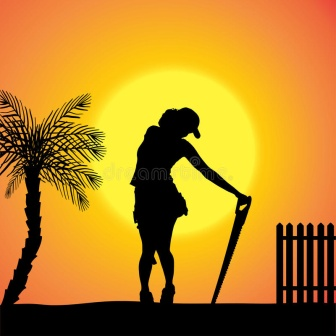What might the sun symbolize in this image? The sun in this image could symbolize a range of themes depending on interpretation. It might represent the passage of time, marking the end of a day and the promise of a new tomorrow. It can also symbolize enlightenment and hope, shining light on the accomplishments of the day's work. Additionally, the vibrant sun could signify life and energy, fueling the growth of plants and sustaining the cycle of labor that the silhouetted figure partakes in. Overall, the sun is a powerful symbol of warmth, renewal, and the constant march of time. 